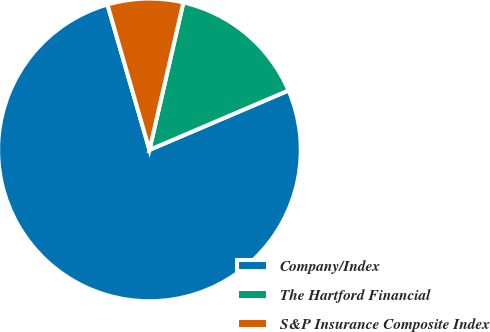Convert chart. <chart><loc_0><loc_0><loc_500><loc_500><pie_chart><fcel>Company/Index<fcel>The Hartford Financial<fcel>S&P Insurance Composite Index<nl><fcel>76.95%<fcel>14.97%<fcel>8.08%<nl></chart> 